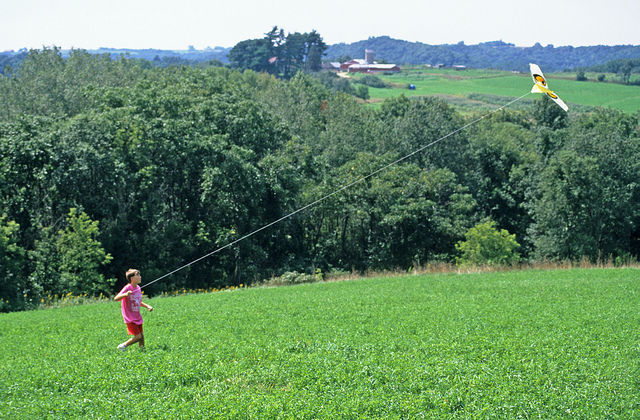Describe a short story of the child who loves flying kites in this meadow. In a peaceful countryside, a child named Alex found joy in flying kites on the grassy hill near their home. Every weekend, they would rush to the meadow with a new kite design, each more colorful than the last. The hillside was Alex's favorite place, the open skies perfect for their spirited kites to dance. One particularly breezy day, Alex's kite soared higher than ever before, almost touching the clouds. As Alex held tightly to the string, feeling the pull of the wind, they felt on top of the world, their heart soaring with the kite. 